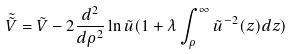<formula> <loc_0><loc_0><loc_500><loc_500>\tilde { \tilde { V } } = \tilde { V } - 2 \frac { d ^ { 2 } } { d \rho ^ { 2 } } \ln \tilde { u } ( 1 + \lambda \int ^ { \infty } _ { \rho } \tilde { u } ^ { - 2 } ( z ) d z )</formula> 